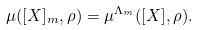<formula> <loc_0><loc_0><loc_500><loc_500>\mu ( [ X ] _ { m } , \rho ) = \mu ^ { \Lambda _ { m } } ( [ X ] , \rho ) .</formula> 